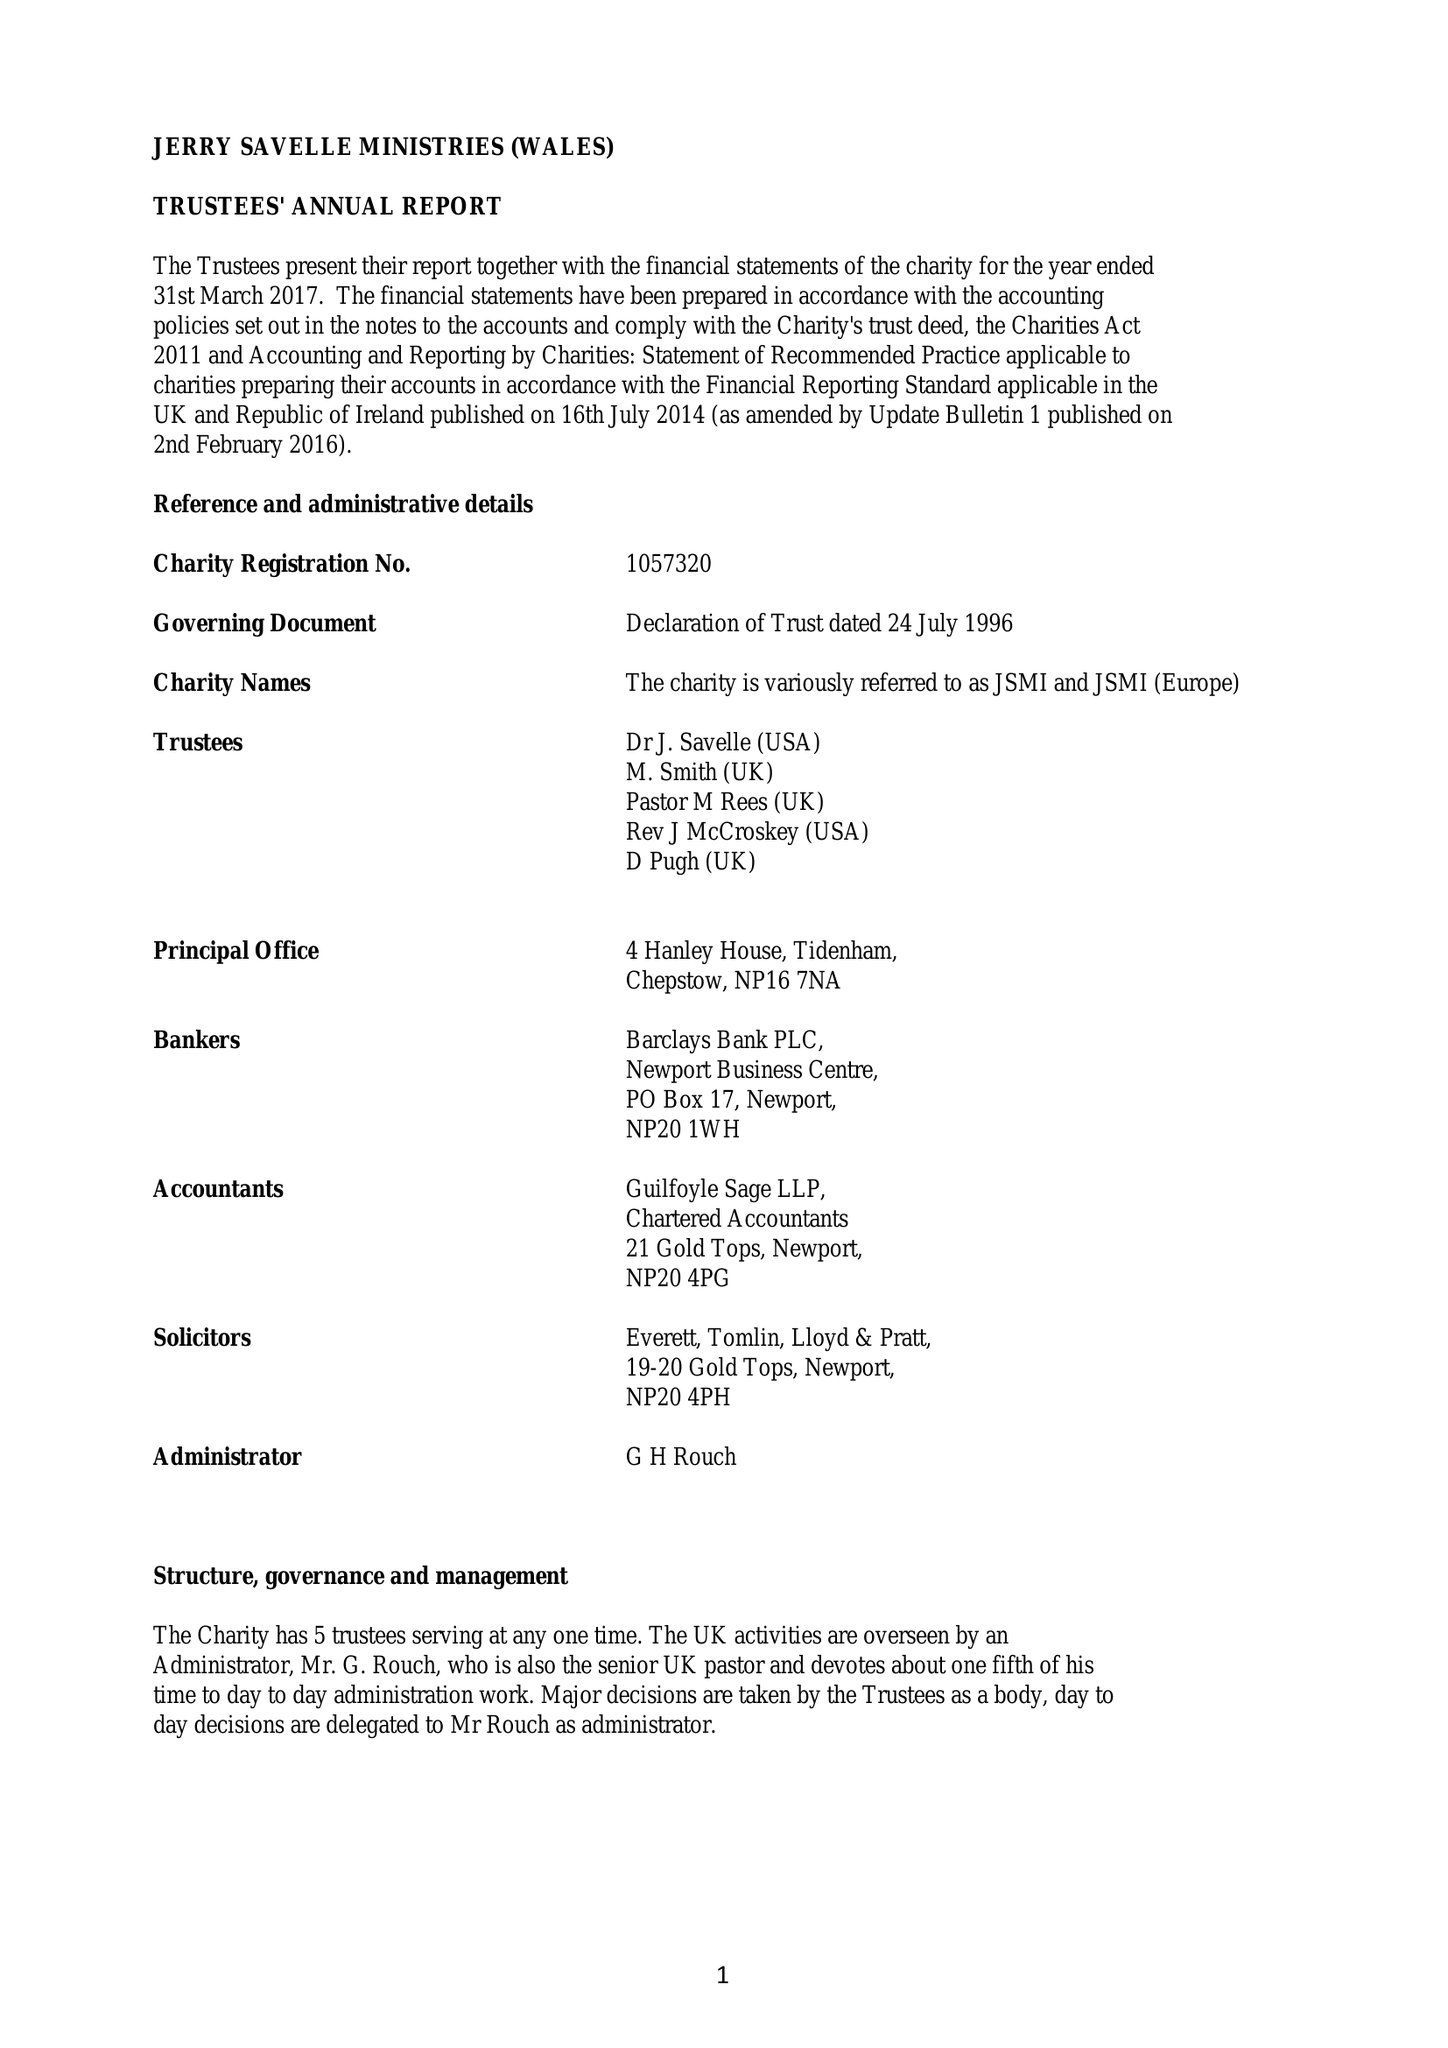What is the value for the income_annually_in_british_pounds?
Answer the question using a single word or phrase. 250259.00 